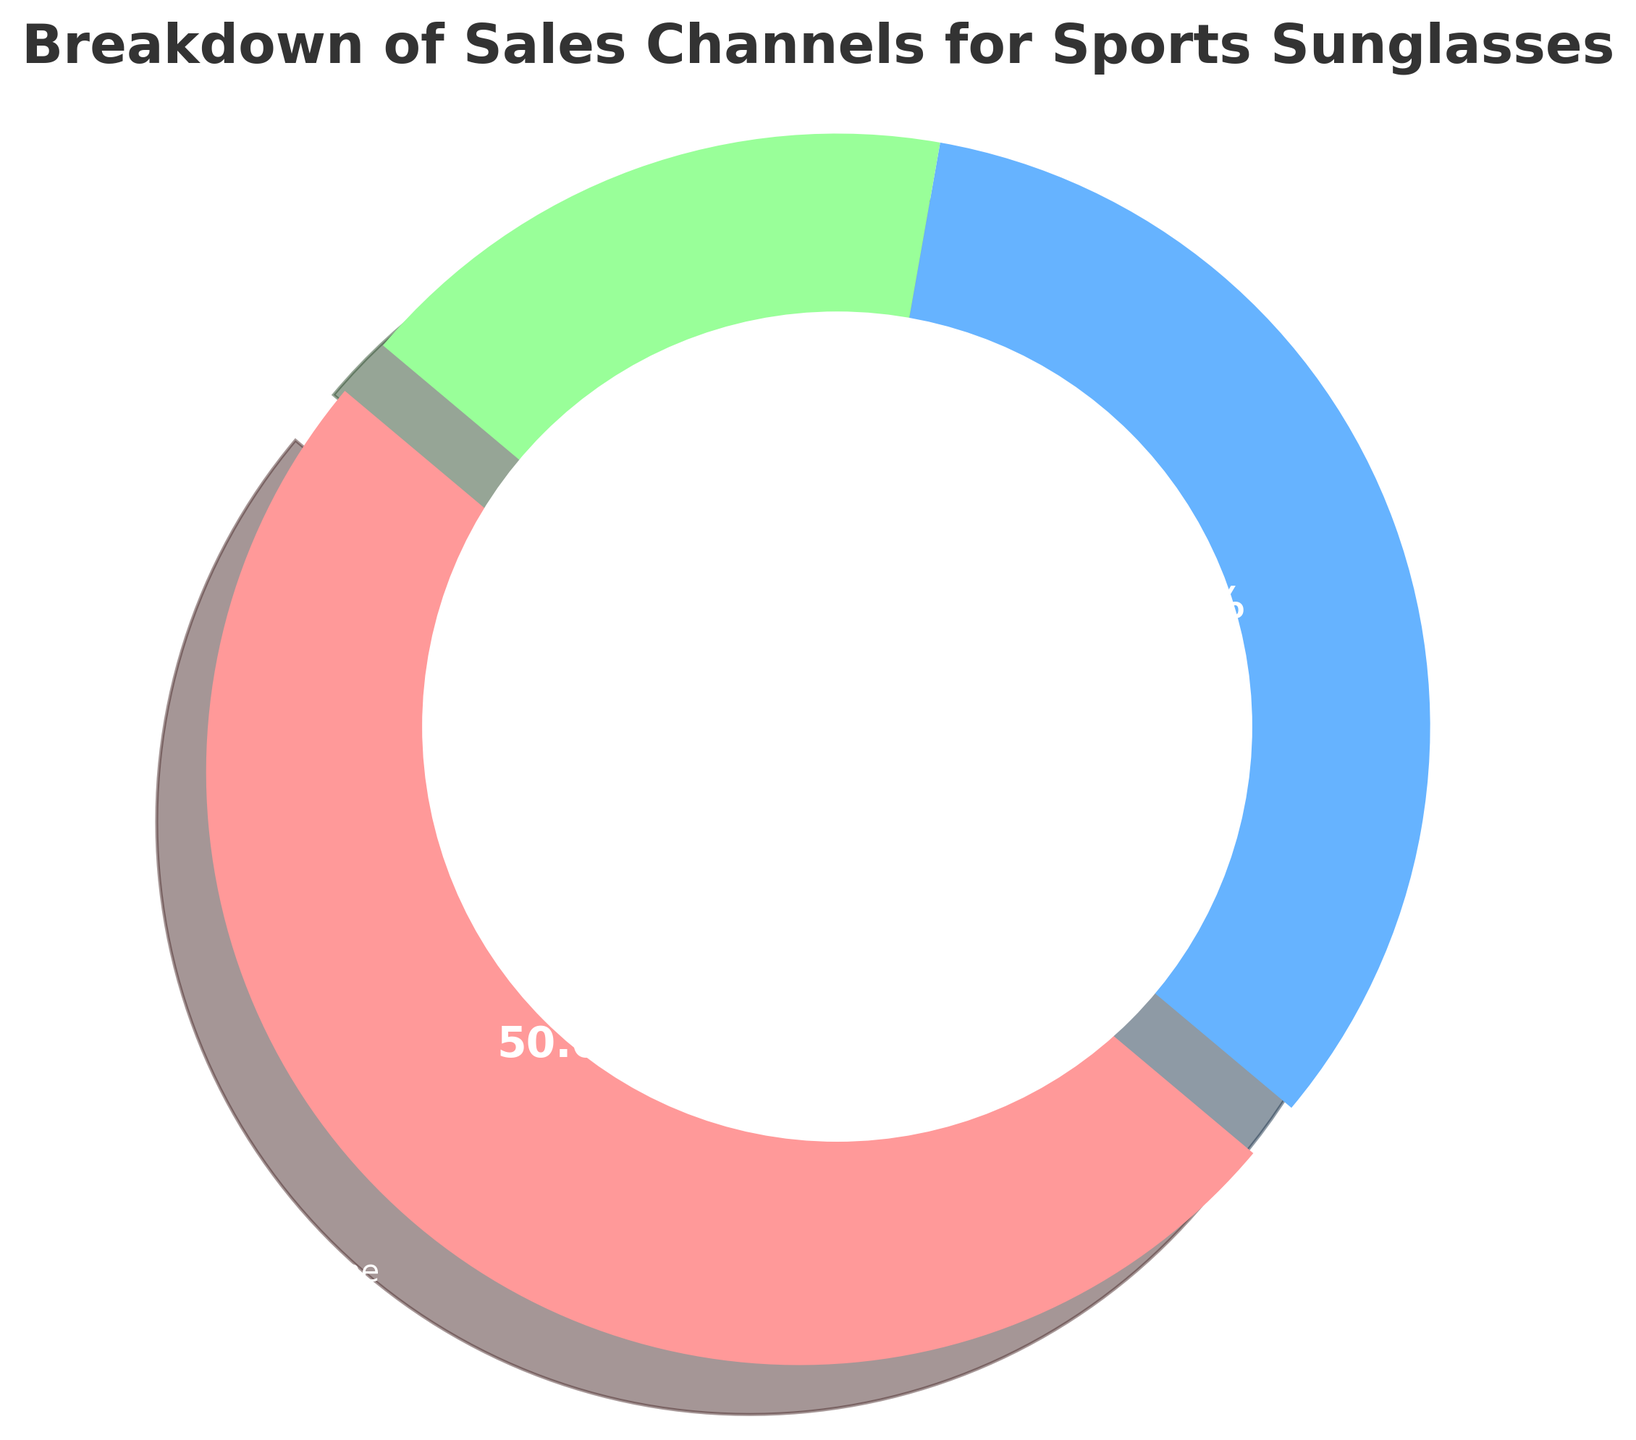How many total sales were made across all channels? To find the total sales, add the sales from all channels together: 450,000 (Online) + 300,000 (Retail) + 150,000 (Events).
Answer: 900,000 Which channel contributed the most to sales? From the pie chart, it's clear that the Online channel has the largest slice, indicating it has the highest sales.
Answer: Online What percentage of the sales comes from retail? From the pie chart, the percentage corresponding to retail sales is shown directly on the chart as 33.3%.
Answer: 33.3% How do Online sales compare to Event sales? Online sales are given as 450,000, and Event sales are 150,000. Online sales are 3 times larger than Event sales.
Answer: Online sales are 3 times larger than Event sales What is the difference between Online and Retail sales? Subtract retail sales from online sales: 450,000 - 300,000.
Answer: 150,000 Which channel has the smallest sales, and what is its percentage? The smallest slice on the pie chart corresponds to Events, and its percentage is labeled as 16.7%.
Answer: Events, 16.7% What proportion of the total sales is represented by non-online channels together? Sum the sales of the Retail and Events channels: 300,000 + 150,000 = 450,000. The total sales are 900,000, so the proportion is 450,000 / 900,000 = 0.5 or 50%.
Answer: 50% By how much do Retail sales exceed Event sales? Subtract Event sales from Retail sales: 300,000 - 150,000.
Answer: 150,000 